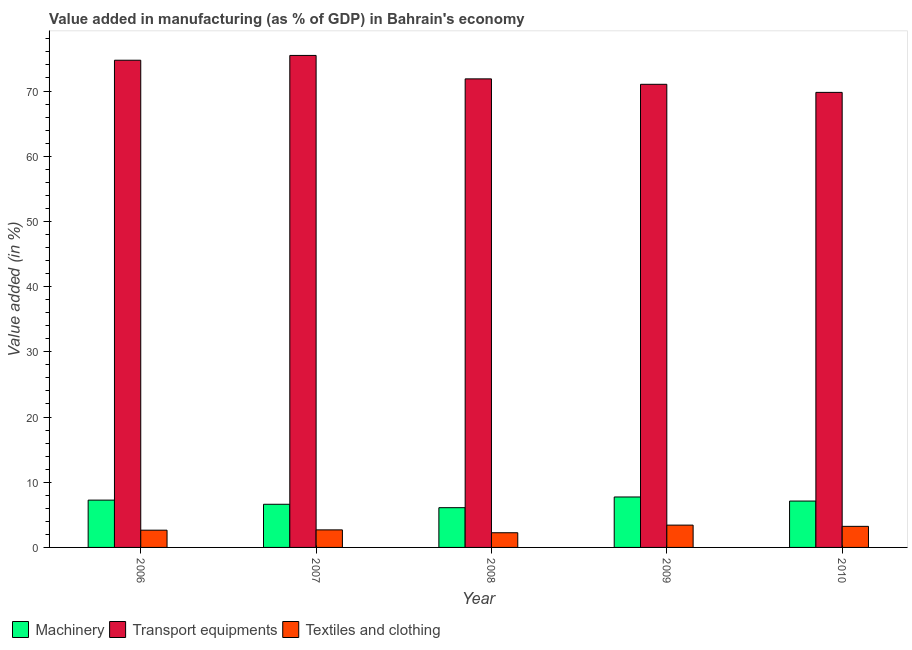How many different coloured bars are there?
Your answer should be compact. 3. How many groups of bars are there?
Ensure brevity in your answer.  5. Are the number of bars per tick equal to the number of legend labels?
Offer a terse response. Yes. Are the number of bars on each tick of the X-axis equal?
Offer a terse response. Yes. In how many cases, is the number of bars for a given year not equal to the number of legend labels?
Provide a short and direct response. 0. What is the value added in manufacturing machinery in 2007?
Make the answer very short. 6.62. Across all years, what is the maximum value added in manufacturing textile and clothing?
Offer a very short reply. 3.42. Across all years, what is the minimum value added in manufacturing machinery?
Keep it short and to the point. 6.1. In which year was the value added in manufacturing machinery maximum?
Offer a terse response. 2009. In which year was the value added in manufacturing transport equipments minimum?
Ensure brevity in your answer.  2010. What is the total value added in manufacturing textile and clothing in the graph?
Keep it short and to the point. 14.24. What is the difference between the value added in manufacturing textile and clothing in 2006 and that in 2007?
Offer a terse response. -0.05. What is the difference between the value added in manufacturing machinery in 2006 and the value added in manufacturing transport equipments in 2009?
Provide a succinct answer. -0.48. What is the average value added in manufacturing transport equipments per year?
Provide a succinct answer. 72.57. What is the ratio of the value added in manufacturing textile and clothing in 2006 to that in 2008?
Provide a succinct answer. 1.17. Is the value added in manufacturing transport equipments in 2007 less than that in 2009?
Ensure brevity in your answer.  No. Is the difference between the value added in manufacturing textile and clothing in 2006 and 2009 greater than the difference between the value added in manufacturing machinery in 2006 and 2009?
Provide a succinct answer. No. What is the difference between the highest and the second highest value added in manufacturing transport equipments?
Keep it short and to the point. 0.74. What is the difference between the highest and the lowest value added in manufacturing transport equipments?
Keep it short and to the point. 5.67. In how many years, is the value added in manufacturing machinery greater than the average value added in manufacturing machinery taken over all years?
Offer a terse response. 3. Is the sum of the value added in manufacturing textile and clothing in 2006 and 2008 greater than the maximum value added in manufacturing machinery across all years?
Your answer should be very brief. Yes. What does the 2nd bar from the left in 2010 represents?
Your response must be concise. Transport equipments. What does the 1st bar from the right in 2006 represents?
Ensure brevity in your answer.  Textiles and clothing. Is it the case that in every year, the sum of the value added in manufacturing machinery and value added in manufacturing transport equipments is greater than the value added in manufacturing textile and clothing?
Your answer should be compact. Yes. How many bars are there?
Your response must be concise. 15. How many years are there in the graph?
Provide a short and direct response. 5. Are the values on the major ticks of Y-axis written in scientific E-notation?
Make the answer very short. No. Does the graph contain grids?
Your answer should be compact. No. Where does the legend appear in the graph?
Keep it short and to the point. Bottom left. How many legend labels are there?
Your answer should be compact. 3. How are the legend labels stacked?
Your response must be concise. Horizontal. What is the title of the graph?
Give a very brief answer. Value added in manufacturing (as % of GDP) in Bahrain's economy. What is the label or title of the X-axis?
Offer a terse response. Year. What is the label or title of the Y-axis?
Give a very brief answer. Value added (in %). What is the Value added (in %) of Machinery in 2006?
Your answer should be very brief. 7.26. What is the Value added (in %) of Transport equipments in 2006?
Your response must be concise. 74.72. What is the Value added (in %) in Textiles and clothing in 2006?
Keep it short and to the point. 2.65. What is the Value added (in %) in Machinery in 2007?
Provide a succinct answer. 6.62. What is the Value added (in %) of Transport equipments in 2007?
Offer a terse response. 75.46. What is the Value added (in %) of Textiles and clothing in 2007?
Your answer should be compact. 2.69. What is the Value added (in %) in Machinery in 2008?
Ensure brevity in your answer.  6.1. What is the Value added (in %) of Transport equipments in 2008?
Ensure brevity in your answer.  71.86. What is the Value added (in %) in Textiles and clothing in 2008?
Offer a very short reply. 2.25. What is the Value added (in %) of Machinery in 2009?
Give a very brief answer. 7.74. What is the Value added (in %) of Transport equipments in 2009?
Offer a terse response. 71.03. What is the Value added (in %) in Textiles and clothing in 2009?
Offer a very short reply. 3.42. What is the Value added (in %) in Machinery in 2010?
Offer a terse response. 7.11. What is the Value added (in %) in Transport equipments in 2010?
Keep it short and to the point. 69.79. What is the Value added (in %) of Textiles and clothing in 2010?
Provide a short and direct response. 3.23. Across all years, what is the maximum Value added (in %) of Machinery?
Make the answer very short. 7.74. Across all years, what is the maximum Value added (in %) in Transport equipments?
Make the answer very short. 75.46. Across all years, what is the maximum Value added (in %) in Textiles and clothing?
Your response must be concise. 3.42. Across all years, what is the minimum Value added (in %) in Machinery?
Your answer should be very brief. 6.1. Across all years, what is the minimum Value added (in %) of Transport equipments?
Make the answer very short. 69.79. Across all years, what is the minimum Value added (in %) of Textiles and clothing?
Your response must be concise. 2.25. What is the total Value added (in %) of Machinery in the graph?
Offer a very short reply. 34.82. What is the total Value added (in %) in Transport equipments in the graph?
Your answer should be compact. 362.85. What is the total Value added (in %) in Textiles and clothing in the graph?
Ensure brevity in your answer.  14.24. What is the difference between the Value added (in %) of Machinery in 2006 and that in 2007?
Your answer should be very brief. 0.64. What is the difference between the Value added (in %) in Transport equipments in 2006 and that in 2007?
Your answer should be very brief. -0.74. What is the difference between the Value added (in %) in Textiles and clothing in 2006 and that in 2007?
Provide a succinct answer. -0.05. What is the difference between the Value added (in %) in Machinery in 2006 and that in 2008?
Your answer should be very brief. 1.16. What is the difference between the Value added (in %) of Transport equipments in 2006 and that in 2008?
Offer a terse response. 2.86. What is the difference between the Value added (in %) of Textiles and clothing in 2006 and that in 2008?
Keep it short and to the point. 0.39. What is the difference between the Value added (in %) in Machinery in 2006 and that in 2009?
Provide a succinct answer. -0.48. What is the difference between the Value added (in %) in Transport equipments in 2006 and that in 2009?
Your answer should be very brief. 3.69. What is the difference between the Value added (in %) of Textiles and clothing in 2006 and that in 2009?
Offer a very short reply. -0.78. What is the difference between the Value added (in %) of Machinery in 2006 and that in 2010?
Your answer should be compact. 0.14. What is the difference between the Value added (in %) in Transport equipments in 2006 and that in 2010?
Your answer should be compact. 4.93. What is the difference between the Value added (in %) of Textiles and clothing in 2006 and that in 2010?
Your answer should be compact. -0.59. What is the difference between the Value added (in %) of Machinery in 2007 and that in 2008?
Your answer should be compact. 0.52. What is the difference between the Value added (in %) of Transport equipments in 2007 and that in 2008?
Your answer should be compact. 3.6. What is the difference between the Value added (in %) in Textiles and clothing in 2007 and that in 2008?
Give a very brief answer. 0.44. What is the difference between the Value added (in %) in Machinery in 2007 and that in 2009?
Your answer should be compact. -1.12. What is the difference between the Value added (in %) in Transport equipments in 2007 and that in 2009?
Keep it short and to the point. 4.43. What is the difference between the Value added (in %) of Textiles and clothing in 2007 and that in 2009?
Keep it short and to the point. -0.73. What is the difference between the Value added (in %) in Machinery in 2007 and that in 2010?
Ensure brevity in your answer.  -0.49. What is the difference between the Value added (in %) in Transport equipments in 2007 and that in 2010?
Your answer should be very brief. 5.67. What is the difference between the Value added (in %) of Textiles and clothing in 2007 and that in 2010?
Your answer should be very brief. -0.54. What is the difference between the Value added (in %) of Machinery in 2008 and that in 2009?
Provide a short and direct response. -1.64. What is the difference between the Value added (in %) in Transport equipments in 2008 and that in 2009?
Provide a succinct answer. 0.83. What is the difference between the Value added (in %) of Textiles and clothing in 2008 and that in 2009?
Provide a short and direct response. -1.17. What is the difference between the Value added (in %) in Machinery in 2008 and that in 2010?
Make the answer very short. -1.02. What is the difference between the Value added (in %) in Transport equipments in 2008 and that in 2010?
Your response must be concise. 2.07. What is the difference between the Value added (in %) in Textiles and clothing in 2008 and that in 2010?
Offer a very short reply. -0.98. What is the difference between the Value added (in %) of Machinery in 2009 and that in 2010?
Make the answer very short. 0.62. What is the difference between the Value added (in %) in Transport equipments in 2009 and that in 2010?
Make the answer very short. 1.24. What is the difference between the Value added (in %) in Textiles and clothing in 2009 and that in 2010?
Your response must be concise. 0.19. What is the difference between the Value added (in %) of Machinery in 2006 and the Value added (in %) of Transport equipments in 2007?
Your response must be concise. -68.2. What is the difference between the Value added (in %) in Machinery in 2006 and the Value added (in %) in Textiles and clothing in 2007?
Offer a terse response. 4.57. What is the difference between the Value added (in %) in Transport equipments in 2006 and the Value added (in %) in Textiles and clothing in 2007?
Your answer should be very brief. 72.03. What is the difference between the Value added (in %) in Machinery in 2006 and the Value added (in %) in Transport equipments in 2008?
Provide a short and direct response. -64.6. What is the difference between the Value added (in %) of Machinery in 2006 and the Value added (in %) of Textiles and clothing in 2008?
Give a very brief answer. 5. What is the difference between the Value added (in %) in Transport equipments in 2006 and the Value added (in %) in Textiles and clothing in 2008?
Your answer should be very brief. 72.47. What is the difference between the Value added (in %) in Machinery in 2006 and the Value added (in %) in Transport equipments in 2009?
Your response must be concise. -63.77. What is the difference between the Value added (in %) in Machinery in 2006 and the Value added (in %) in Textiles and clothing in 2009?
Give a very brief answer. 3.83. What is the difference between the Value added (in %) in Transport equipments in 2006 and the Value added (in %) in Textiles and clothing in 2009?
Provide a succinct answer. 71.3. What is the difference between the Value added (in %) of Machinery in 2006 and the Value added (in %) of Transport equipments in 2010?
Offer a very short reply. -62.53. What is the difference between the Value added (in %) of Machinery in 2006 and the Value added (in %) of Textiles and clothing in 2010?
Provide a succinct answer. 4.02. What is the difference between the Value added (in %) of Transport equipments in 2006 and the Value added (in %) of Textiles and clothing in 2010?
Give a very brief answer. 71.49. What is the difference between the Value added (in %) of Machinery in 2007 and the Value added (in %) of Transport equipments in 2008?
Keep it short and to the point. -65.24. What is the difference between the Value added (in %) in Machinery in 2007 and the Value added (in %) in Textiles and clothing in 2008?
Provide a succinct answer. 4.37. What is the difference between the Value added (in %) of Transport equipments in 2007 and the Value added (in %) of Textiles and clothing in 2008?
Give a very brief answer. 73.2. What is the difference between the Value added (in %) of Machinery in 2007 and the Value added (in %) of Transport equipments in 2009?
Give a very brief answer. -64.41. What is the difference between the Value added (in %) in Machinery in 2007 and the Value added (in %) in Textiles and clothing in 2009?
Offer a very short reply. 3.2. What is the difference between the Value added (in %) in Transport equipments in 2007 and the Value added (in %) in Textiles and clothing in 2009?
Provide a succinct answer. 72.03. What is the difference between the Value added (in %) of Machinery in 2007 and the Value added (in %) of Transport equipments in 2010?
Offer a terse response. -63.17. What is the difference between the Value added (in %) in Machinery in 2007 and the Value added (in %) in Textiles and clothing in 2010?
Your response must be concise. 3.39. What is the difference between the Value added (in %) in Transport equipments in 2007 and the Value added (in %) in Textiles and clothing in 2010?
Offer a very short reply. 72.22. What is the difference between the Value added (in %) of Machinery in 2008 and the Value added (in %) of Transport equipments in 2009?
Offer a terse response. -64.93. What is the difference between the Value added (in %) of Machinery in 2008 and the Value added (in %) of Textiles and clothing in 2009?
Make the answer very short. 2.67. What is the difference between the Value added (in %) in Transport equipments in 2008 and the Value added (in %) in Textiles and clothing in 2009?
Your answer should be compact. 68.44. What is the difference between the Value added (in %) in Machinery in 2008 and the Value added (in %) in Transport equipments in 2010?
Your answer should be compact. -63.69. What is the difference between the Value added (in %) in Machinery in 2008 and the Value added (in %) in Textiles and clothing in 2010?
Offer a very short reply. 2.86. What is the difference between the Value added (in %) in Transport equipments in 2008 and the Value added (in %) in Textiles and clothing in 2010?
Offer a terse response. 68.63. What is the difference between the Value added (in %) of Machinery in 2009 and the Value added (in %) of Transport equipments in 2010?
Provide a succinct answer. -62.05. What is the difference between the Value added (in %) of Machinery in 2009 and the Value added (in %) of Textiles and clothing in 2010?
Provide a short and direct response. 4.5. What is the difference between the Value added (in %) of Transport equipments in 2009 and the Value added (in %) of Textiles and clothing in 2010?
Give a very brief answer. 67.8. What is the average Value added (in %) in Machinery per year?
Your response must be concise. 6.96. What is the average Value added (in %) in Transport equipments per year?
Ensure brevity in your answer.  72.57. What is the average Value added (in %) in Textiles and clothing per year?
Your answer should be compact. 2.85. In the year 2006, what is the difference between the Value added (in %) in Machinery and Value added (in %) in Transport equipments?
Provide a succinct answer. -67.46. In the year 2006, what is the difference between the Value added (in %) of Machinery and Value added (in %) of Textiles and clothing?
Keep it short and to the point. 4.61. In the year 2006, what is the difference between the Value added (in %) in Transport equipments and Value added (in %) in Textiles and clothing?
Keep it short and to the point. 72.08. In the year 2007, what is the difference between the Value added (in %) of Machinery and Value added (in %) of Transport equipments?
Ensure brevity in your answer.  -68.84. In the year 2007, what is the difference between the Value added (in %) of Machinery and Value added (in %) of Textiles and clothing?
Keep it short and to the point. 3.93. In the year 2007, what is the difference between the Value added (in %) of Transport equipments and Value added (in %) of Textiles and clothing?
Your answer should be compact. 72.77. In the year 2008, what is the difference between the Value added (in %) of Machinery and Value added (in %) of Transport equipments?
Give a very brief answer. -65.76. In the year 2008, what is the difference between the Value added (in %) of Machinery and Value added (in %) of Textiles and clothing?
Your answer should be very brief. 3.84. In the year 2008, what is the difference between the Value added (in %) in Transport equipments and Value added (in %) in Textiles and clothing?
Your answer should be compact. 69.61. In the year 2009, what is the difference between the Value added (in %) of Machinery and Value added (in %) of Transport equipments?
Offer a terse response. -63.29. In the year 2009, what is the difference between the Value added (in %) of Machinery and Value added (in %) of Textiles and clothing?
Provide a succinct answer. 4.31. In the year 2009, what is the difference between the Value added (in %) in Transport equipments and Value added (in %) in Textiles and clothing?
Your answer should be very brief. 67.61. In the year 2010, what is the difference between the Value added (in %) of Machinery and Value added (in %) of Transport equipments?
Give a very brief answer. -62.67. In the year 2010, what is the difference between the Value added (in %) of Machinery and Value added (in %) of Textiles and clothing?
Offer a very short reply. 3.88. In the year 2010, what is the difference between the Value added (in %) of Transport equipments and Value added (in %) of Textiles and clothing?
Make the answer very short. 66.56. What is the ratio of the Value added (in %) of Machinery in 2006 to that in 2007?
Your response must be concise. 1.1. What is the ratio of the Value added (in %) in Transport equipments in 2006 to that in 2007?
Provide a succinct answer. 0.99. What is the ratio of the Value added (in %) in Textiles and clothing in 2006 to that in 2007?
Ensure brevity in your answer.  0.98. What is the ratio of the Value added (in %) in Machinery in 2006 to that in 2008?
Ensure brevity in your answer.  1.19. What is the ratio of the Value added (in %) of Transport equipments in 2006 to that in 2008?
Your response must be concise. 1.04. What is the ratio of the Value added (in %) of Textiles and clothing in 2006 to that in 2008?
Your response must be concise. 1.17. What is the ratio of the Value added (in %) in Machinery in 2006 to that in 2009?
Make the answer very short. 0.94. What is the ratio of the Value added (in %) of Transport equipments in 2006 to that in 2009?
Your answer should be compact. 1.05. What is the ratio of the Value added (in %) of Textiles and clothing in 2006 to that in 2009?
Provide a short and direct response. 0.77. What is the ratio of the Value added (in %) in Machinery in 2006 to that in 2010?
Ensure brevity in your answer.  1.02. What is the ratio of the Value added (in %) of Transport equipments in 2006 to that in 2010?
Ensure brevity in your answer.  1.07. What is the ratio of the Value added (in %) of Textiles and clothing in 2006 to that in 2010?
Keep it short and to the point. 0.82. What is the ratio of the Value added (in %) in Machinery in 2007 to that in 2008?
Provide a short and direct response. 1.09. What is the ratio of the Value added (in %) of Transport equipments in 2007 to that in 2008?
Offer a terse response. 1.05. What is the ratio of the Value added (in %) of Textiles and clothing in 2007 to that in 2008?
Ensure brevity in your answer.  1.2. What is the ratio of the Value added (in %) of Machinery in 2007 to that in 2009?
Ensure brevity in your answer.  0.86. What is the ratio of the Value added (in %) of Transport equipments in 2007 to that in 2009?
Your answer should be compact. 1.06. What is the ratio of the Value added (in %) in Textiles and clothing in 2007 to that in 2009?
Provide a short and direct response. 0.79. What is the ratio of the Value added (in %) in Machinery in 2007 to that in 2010?
Provide a short and direct response. 0.93. What is the ratio of the Value added (in %) of Transport equipments in 2007 to that in 2010?
Ensure brevity in your answer.  1.08. What is the ratio of the Value added (in %) of Textiles and clothing in 2007 to that in 2010?
Provide a succinct answer. 0.83. What is the ratio of the Value added (in %) of Machinery in 2008 to that in 2009?
Offer a very short reply. 0.79. What is the ratio of the Value added (in %) of Transport equipments in 2008 to that in 2009?
Give a very brief answer. 1.01. What is the ratio of the Value added (in %) in Textiles and clothing in 2008 to that in 2009?
Make the answer very short. 0.66. What is the ratio of the Value added (in %) of Machinery in 2008 to that in 2010?
Ensure brevity in your answer.  0.86. What is the ratio of the Value added (in %) in Transport equipments in 2008 to that in 2010?
Your answer should be compact. 1.03. What is the ratio of the Value added (in %) of Textiles and clothing in 2008 to that in 2010?
Offer a very short reply. 0.7. What is the ratio of the Value added (in %) in Machinery in 2009 to that in 2010?
Your response must be concise. 1.09. What is the ratio of the Value added (in %) in Transport equipments in 2009 to that in 2010?
Your answer should be compact. 1.02. What is the ratio of the Value added (in %) in Textiles and clothing in 2009 to that in 2010?
Give a very brief answer. 1.06. What is the difference between the highest and the second highest Value added (in %) in Machinery?
Provide a short and direct response. 0.48. What is the difference between the highest and the second highest Value added (in %) of Transport equipments?
Give a very brief answer. 0.74. What is the difference between the highest and the second highest Value added (in %) of Textiles and clothing?
Provide a short and direct response. 0.19. What is the difference between the highest and the lowest Value added (in %) of Machinery?
Offer a terse response. 1.64. What is the difference between the highest and the lowest Value added (in %) in Transport equipments?
Offer a terse response. 5.67. What is the difference between the highest and the lowest Value added (in %) in Textiles and clothing?
Your answer should be very brief. 1.17. 